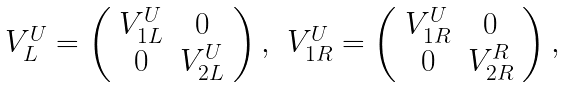<formula> <loc_0><loc_0><loc_500><loc_500>\begin{array} { c c } V ^ { U } _ { L } = \left ( \begin{array} { c c } V ^ { U } _ { 1 L } & 0 \\ 0 & V ^ { U } _ { 2 L } \end{array} \right ) , & V ^ { U } _ { 1 R } = \left ( \begin{array} { c c } V ^ { U } _ { 1 R } & 0 \\ 0 & V ^ { R } _ { 2 R } \end{array} \right ) , \end{array}</formula> 